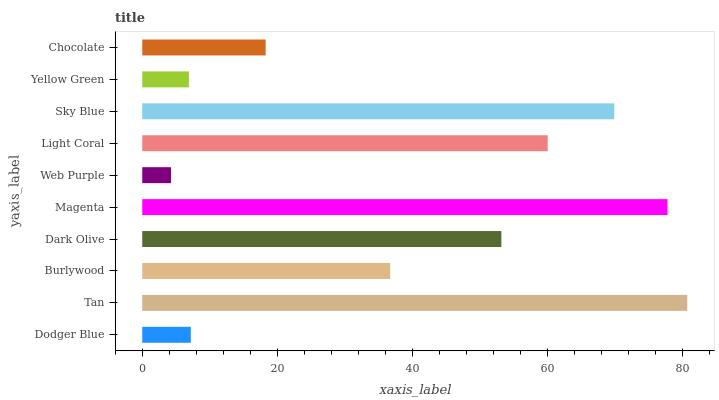Is Web Purple the minimum?
Answer yes or no. Yes. Is Tan the maximum?
Answer yes or no. Yes. Is Burlywood the minimum?
Answer yes or no. No. Is Burlywood the maximum?
Answer yes or no. No. Is Tan greater than Burlywood?
Answer yes or no. Yes. Is Burlywood less than Tan?
Answer yes or no. Yes. Is Burlywood greater than Tan?
Answer yes or no. No. Is Tan less than Burlywood?
Answer yes or no. No. Is Dark Olive the high median?
Answer yes or no. Yes. Is Burlywood the low median?
Answer yes or no. Yes. Is Light Coral the high median?
Answer yes or no. No. Is Chocolate the low median?
Answer yes or no. No. 